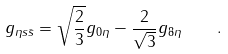Convert formula to latex. <formula><loc_0><loc_0><loc_500><loc_500>g _ { \eta s \bar { s } } = \sqrt { \frac { 2 } { 3 } } g _ { 0 \eta } - \frac { 2 } { \sqrt { 3 } } g _ { 8 \eta } \quad .</formula> 